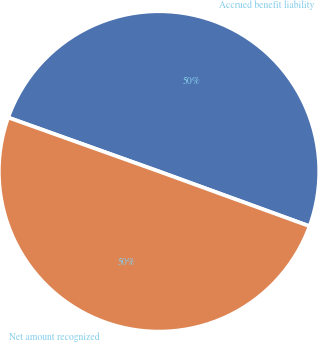<chart> <loc_0><loc_0><loc_500><loc_500><pie_chart><fcel>Accrued benefit liability<fcel>Net amount recognized<nl><fcel>50.09%<fcel>49.91%<nl></chart> 